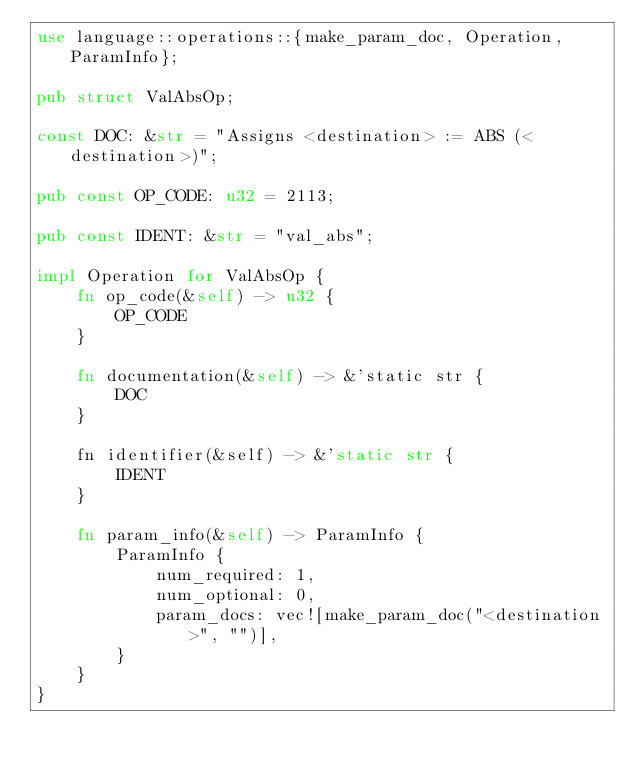<code> <loc_0><loc_0><loc_500><loc_500><_Rust_>use language::operations::{make_param_doc, Operation, ParamInfo};

pub struct ValAbsOp;

const DOC: &str = "Assigns <destination> := ABS (<destination>)";

pub const OP_CODE: u32 = 2113;

pub const IDENT: &str = "val_abs";

impl Operation for ValAbsOp {
    fn op_code(&self) -> u32 {
        OP_CODE
    }

    fn documentation(&self) -> &'static str {
        DOC
    }

    fn identifier(&self) -> &'static str {
        IDENT
    }

    fn param_info(&self) -> ParamInfo {
        ParamInfo {
            num_required: 1,
            num_optional: 0,
            param_docs: vec![make_param_doc("<destination>", "")],
        }
    }
}
</code> 